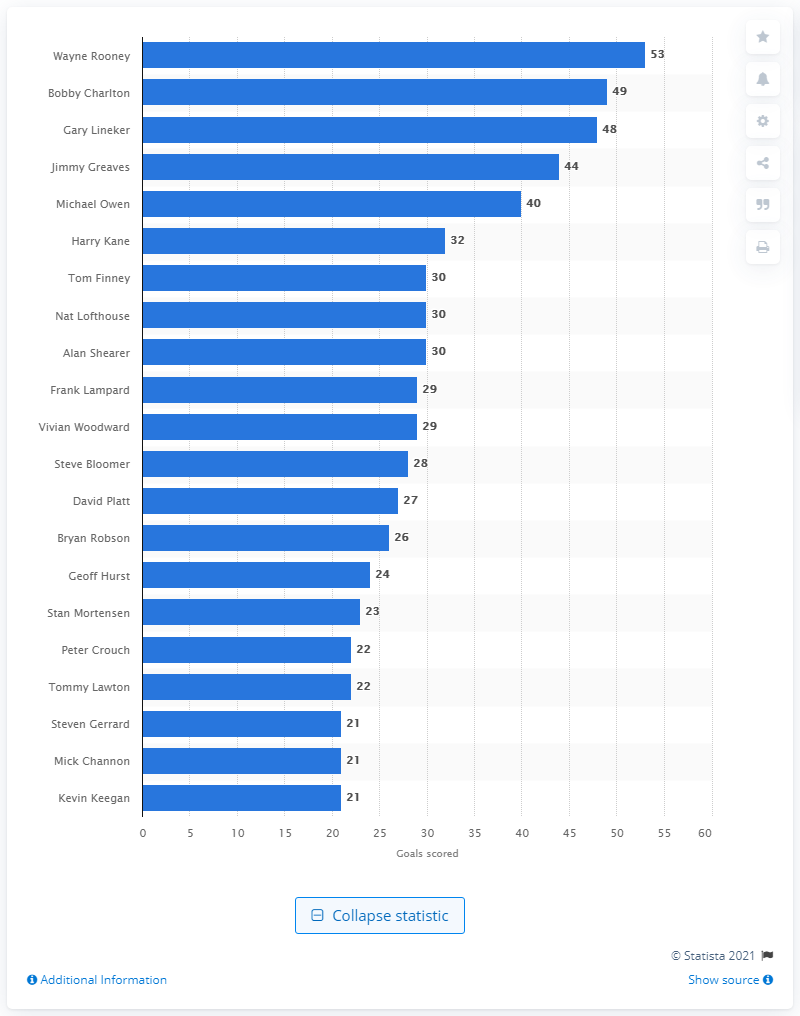Indicate a few pertinent items in this graphic. In his 15-year career, Wayne Rooney scored a total of 53 goals. Wayne Rooney is widely regarded as one of the most successful players in the history of English football. 